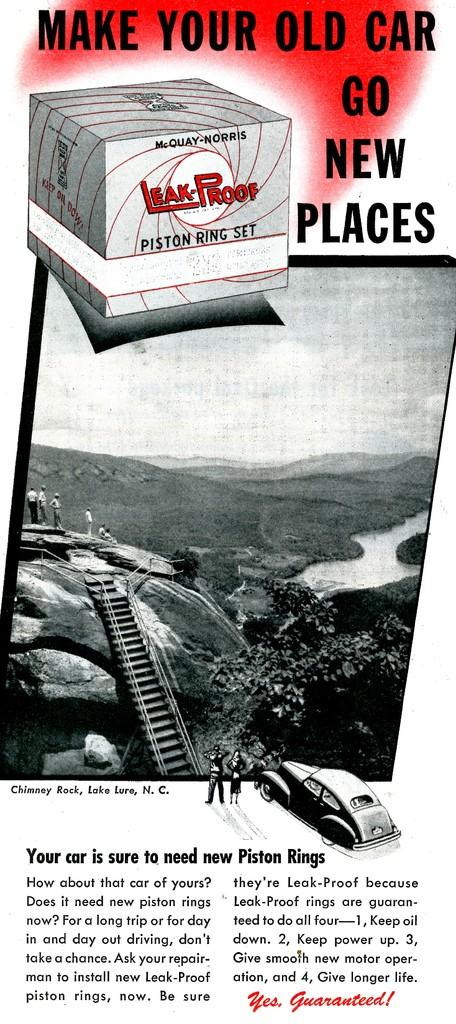<image>
Offer a succinct explanation of the picture presented. A poster saying make your old car go new places. 